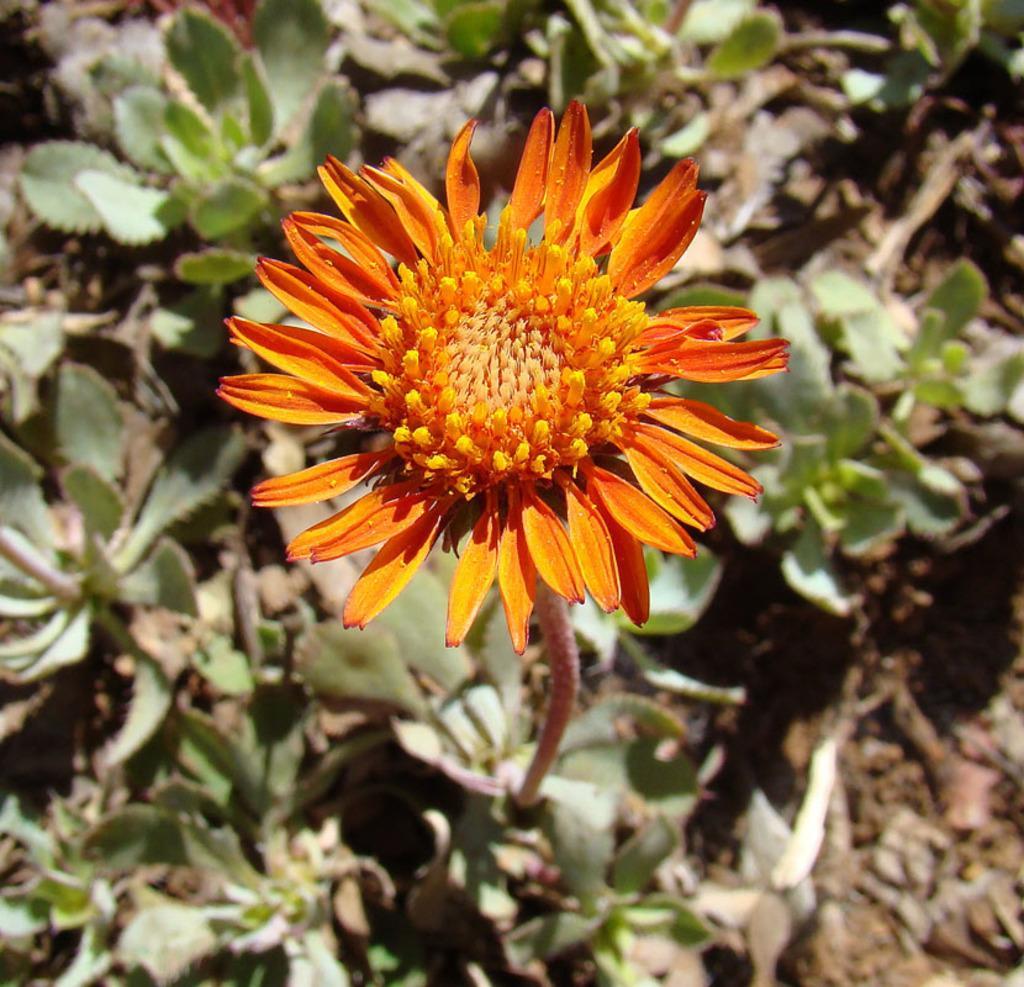How would you summarize this image in a sentence or two? In this picture we can see a flower and in the background we can see planets on the ground. 